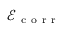Convert formula to latex. <formula><loc_0><loc_0><loc_500><loc_500>\mathcal { E } _ { c o r r }</formula> 